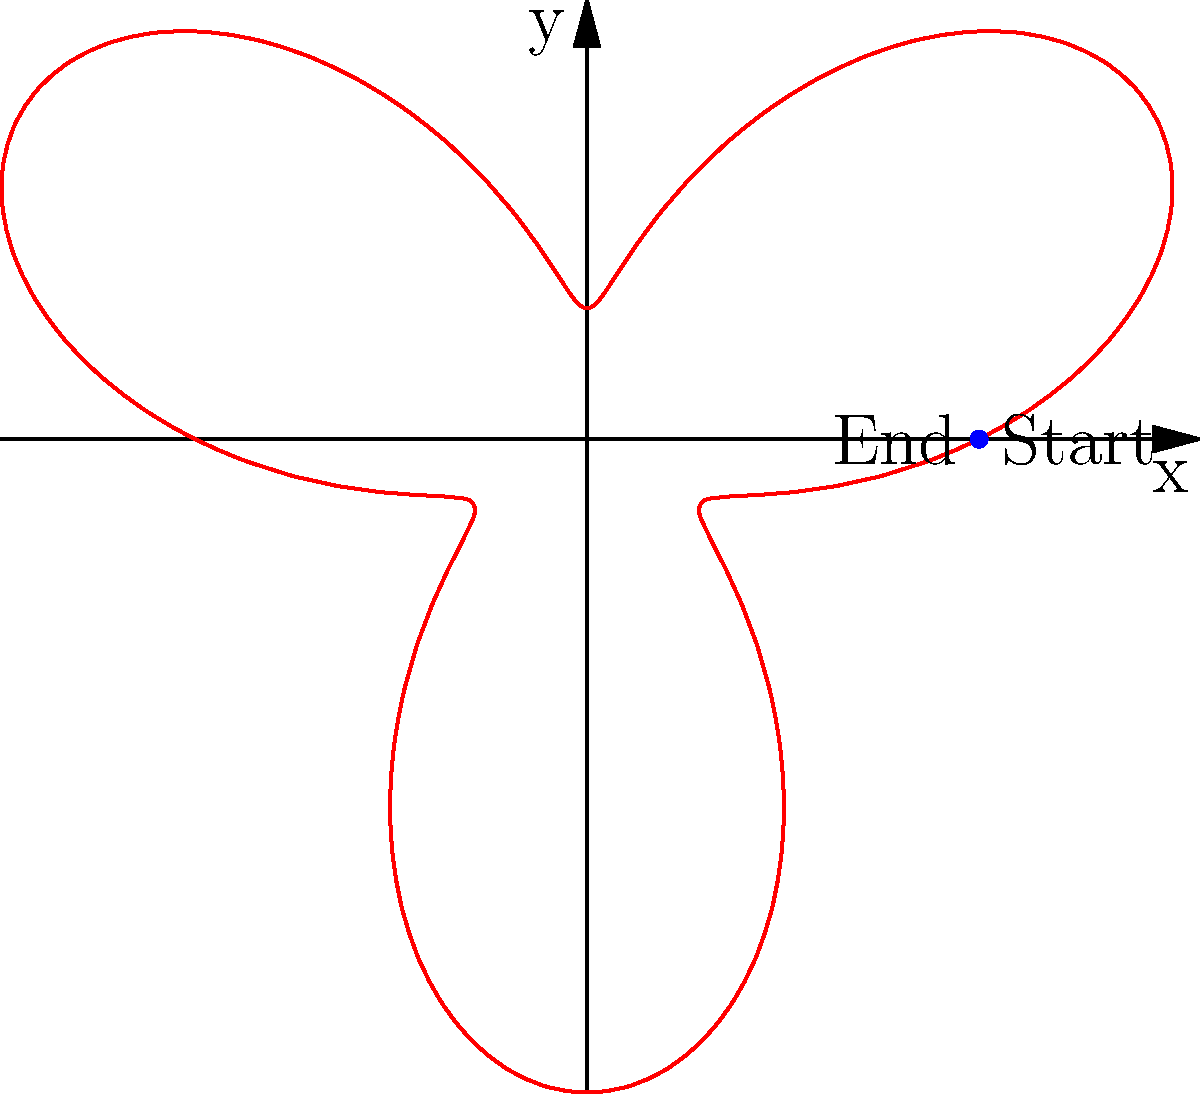In a magical duel, a wizard casts a spell that follows a path described by the polar equation $r = 3 + 2\sin(3\theta)$. If the spell starts and ends at the point $(3,0)$, how many complete loops does the spell's path make before returning to its starting point? To solve this, let's follow these steps:

1) First, we need to understand what determines a complete loop in polar coordinates. A loop is completed when $\theta$ increases by $2\pi$ radians.

2) In our equation $r = 3 + 2\sin(3\theta)$, the periodic part is $\sin(3\theta)$. This means the pattern will repeat every time $3\theta$ increases by $2\pi$.

3) Let's set up an equation:
   $3\theta = 2\pi$

4) Solving for $\theta$:
   $\theta = \frac{2\pi}{3}$

5) This means one-third of a loop is completed when $\theta = \frac{2\pi}{3}$.

6) To complete a full loop and return to the starting point, we need $\theta$ to be a multiple of $2\pi$. The least common multiple of $\frac{2\pi}{3}$ and $2\pi$ is $2\pi$.

7) Therefore, the spell will return to its starting point when $\theta = 2\pi$.

8) During this time, the spell will have made 3 complete loops, because $2\pi \div \frac{2\pi}{3} = 3$.

Thus, the spell's path makes 3 complete loops before returning to its starting point.
Answer: 3 loops 